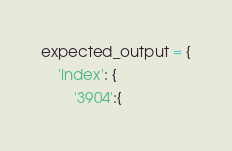Convert code to text. <code><loc_0><loc_0><loc_500><loc_500><_Python_>expected_output = {
    'index': {
        '3904':{</code> 